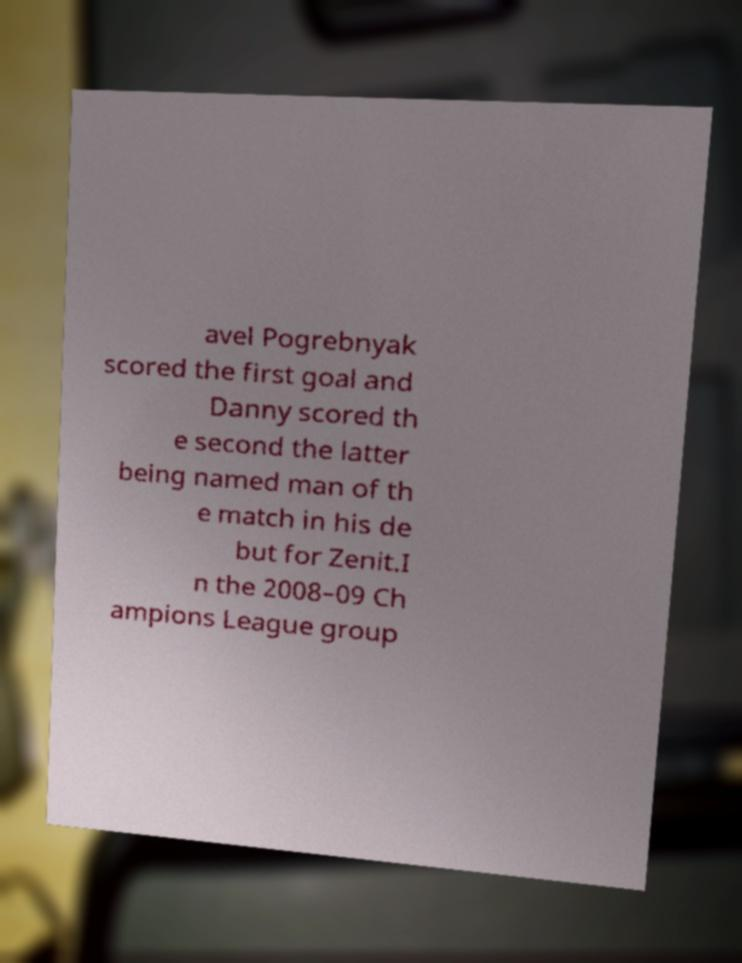For documentation purposes, I need the text within this image transcribed. Could you provide that? avel Pogrebnyak scored the first goal and Danny scored th e second the latter being named man of th e match in his de but for Zenit.I n the 2008–09 Ch ampions League group 